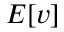<formula> <loc_0><loc_0><loc_500><loc_500>E [ v ]</formula> 